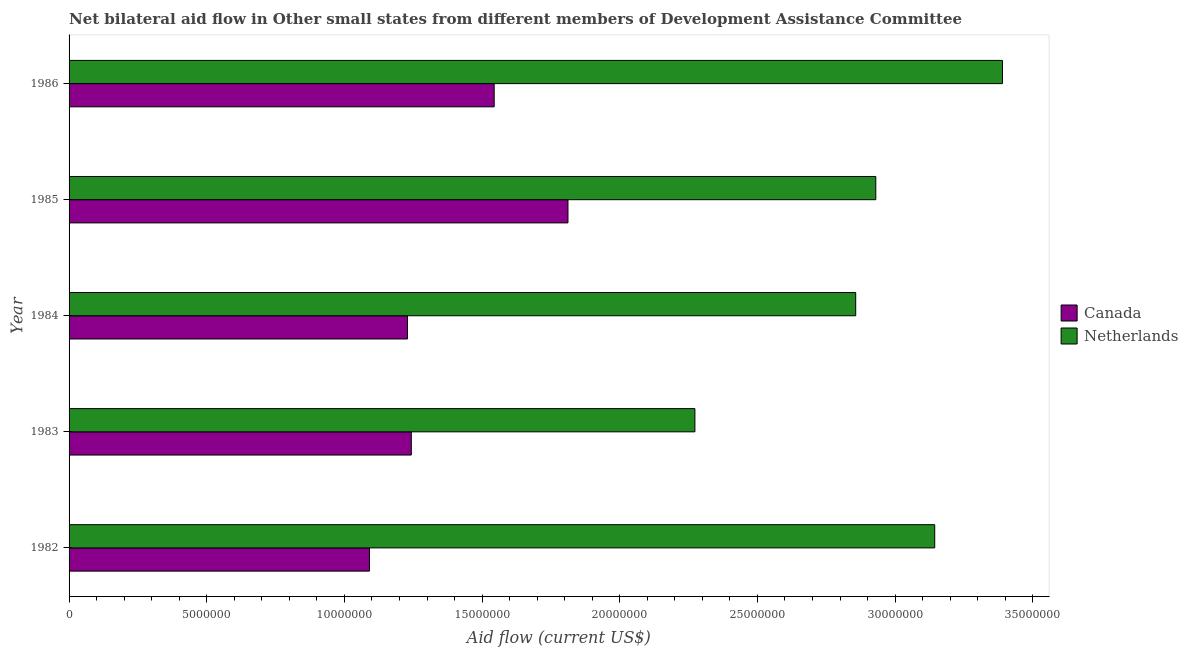How many groups of bars are there?
Your answer should be compact. 5. Are the number of bars per tick equal to the number of legend labels?
Offer a terse response. Yes. Are the number of bars on each tick of the Y-axis equal?
Your response must be concise. Yes. In how many cases, is the number of bars for a given year not equal to the number of legend labels?
Provide a succinct answer. 0. What is the amount of aid given by netherlands in 1985?
Provide a short and direct response. 2.93e+07. Across all years, what is the maximum amount of aid given by canada?
Offer a terse response. 1.81e+07. Across all years, what is the minimum amount of aid given by canada?
Offer a terse response. 1.09e+07. In which year was the amount of aid given by netherlands maximum?
Keep it short and to the point. 1986. What is the total amount of aid given by netherlands in the graph?
Keep it short and to the point. 1.46e+08. What is the difference between the amount of aid given by canada in 1982 and that in 1984?
Your answer should be very brief. -1.38e+06. What is the difference between the amount of aid given by netherlands in 1982 and the amount of aid given by canada in 1984?
Give a very brief answer. 1.92e+07. What is the average amount of aid given by netherlands per year?
Keep it short and to the point. 2.92e+07. In the year 1982, what is the difference between the amount of aid given by canada and amount of aid given by netherlands?
Provide a succinct answer. -2.05e+07. In how many years, is the amount of aid given by canada greater than 31000000 US$?
Offer a very short reply. 0. What is the ratio of the amount of aid given by netherlands in 1983 to that in 1986?
Ensure brevity in your answer.  0.67. Is the difference between the amount of aid given by netherlands in 1982 and 1983 greater than the difference between the amount of aid given by canada in 1982 and 1983?
Give a very brief answer. Yes. What is the difference between the highest and the second highest amount of aid given by canada?
Keep it short and to the point. 2.68e+06. What is the difference between the highest and the lowest amount of aid given by netherlands?
Ensure brevity in your answer.  1.12e+07. In how many years, is the amount of aid given by netherlands greater than the average amount of aid given by netherlands taken over all years?
Your answer should be very brief. 3. Is the sum of the amount of aid given by canada in 1985 and 1986 greater than the maximum amount of aid given by netherlands across all years?
Your answer should be compact. No. What does the 1st bar from the top in 1986 represents?
Offer a terse response. Netherlands. What does the 1st bar from the bottom in 1986 represents?
Make the answer very short. Canada. Are all the bars in the graph horizontal?
Keep it short and to the point. Yes. Does the graph contain grids?
Ensure brevity in your answer.  No. Where does the legend appear in the graph?
Provide a succinct answer. Center right. What is the title of the graph?
Ensure brevity in your answer.  Net bilateral aid flow in Other small states from different members of Development Assistance Committee. Does "External balance on goods" appear as one of the legend labels in the graph?
Your answer should be very brief. No. What is the Aid flow (current US$) of Canada in 1982?
Offer a terse response. 1.09e+07. What is the Aid flow (current US$) of Netherlands in 1982?
Offer a very short reply. 3.14e+07. What is the Aid flow (current US$) in Canada in 1983?
Make the answer very short. 1.24e+07. What is the Aid flow (current US$) of Netherlands in 1983?
Your answer should be compact. 2.27e+07. What is the Aid flow (current US$) in Canada in 1984?
Keep it short and to the point. 1.23e+07. What is the Aid flow (current US$) in Netherlands in 1984?
Your answer should be compact. 2.86e+07. What is the Aid flow (current US$) of Canada in 1985?
Provide a short and direct response. 1.81e+07. What is the Aid flow (current US$) of Netherlands in 1985?
Your response must be concise. 2.93e+07. What is the Aid flow (current US$) of Canada in 1986?
Offer a very short reply. 1.54e+07. What is the Aid flow (current US$) of Netherlands in 1986?
Your answer should be very brief. 3.39e+07. Across all years, what is the maximum Aid flow (current US$) in Canada?
Your answer should be very brief. 1.81e+07. Across all years, what is the maximum Aid flow (current US$) of Netherlands?
Offer a very short reply. 3.39e+07. Across all years, what is the minimum Aid flow (current US$) of Canada?
Keep it short and to the point. 1.09e+07. Across all years, what is the minimum Aid flow (current US$) in Netherlands?
Keep it short and to the point. 2.27e+07. What is the total Aid flow (current US$) in Canada in the graph?
Offer a terse response. 6.92e+07. What is the total Aid flow (current US$) in Netherlands in the graph?
Make the answer very short. 1.46e+08. What is the difference between the Aid flow (current US$) in Canada in 1982 and that in 1983?
Your response must be concise. -1.52e+06. What is the difference between the Aid flow (current US$) in Netherlands in 1982 and that in 1983?
Ensure brevity in your answer.  8.71e+06. What is the difference between the Aid flow (current US$) in Canada in 1982 and that in 1984?
Provide a short and direct response. -1.38e+06. What is the difference between the Aid flow (current US$) of Netherlands in 1982 and that in 1984?
Keep it short and to the point. 2.87e+06. What is the difference between the Aid flow (current US$) of Canada in 1982 and that in 1985?
Your response must be concise. -7.21e+06. What is the difference between the Aid flow (current US$) of Netherlands in 1982 and that in 1985?
Offer a very short reply. 2.14e+06. What is the difference between the Aid flow (current US$) in Canada in 1982 and that in 1986?
Offer a very short reply. -4.53e+06. What is the difference between the Aid flow (current US$) in Netherlands in 1982 and that in 1986?
Your answer should be very brief. -2.46e+06. What is the difference between the Aid flow (current US$) of Netherlands in 1983 and that in 1984?
Your response must be concise. -5.84e+06. What is the difference between the Aid flow (current US$) in Canada in 1983 and that in 1985?
Your response must be concise. -5.69e+06. What is the difference between the Aid flow (current US$) in Netherlands in 1983 and that in 1985?
Keep it short and to the point. -6.57e+06. What is the difference between the Aid flow (current US$) of Canada in 1983 and that in 1986?
Offer a terse response. -3.01e+06. What is the difference between the Aid flow (current US$) in Netherlands in 1983 and that in 1986?
Provide a short and direct response. -1.12e+07. What is the difference between the Aid flow (current US$) in Canada in 1984 and that in 1985?
Make the answer very short. -5.83e+06. What is the difference between the Aid flow (current US$) in Netherlands in 1984 and that in 1985?
Provide a short and direct response. -7.30e+05. What is the difference between the Aid flow (current US$) in Canada in 1984 and that in 1986?
Give a very brief answer. -3.15e+06. What is the difference between the Aid flow (current US$) in Netherlands in 1984 and that in 1986?
Provide a short and direct response. -5.33e+06. What is the difference between the Aid flow (current US$) in Canada in 1985 and that in 1986?
Offer a terse response. 2.68e+06. What is the difference between the Aid flow (current US$) in Netherlands in 1985 and that in 1986?
Provide a succinct answer. -4.60e+06. What is the difference between the Aid flow (current US$) in Canada in 1982 and the Aid flow (current US$) in Netherlands in 1983?
Offer a terse response. -1.18e+07. What is the difference between the Aid flow (current US$) in Canada in 1982 and the Aid flow (current US$) in Netherlands in 1984?
Your answer should be very brief. -1.77e+07. What is the difference between the Aid flow (current US$) of Canada in 1982 and the Aid flow (current US$) of Netherlands in 1985?
Make the answer very short. -1.84e+07. What is the difference between the Aid flow (current US$) in Canada in 1982 and the Aid flow (current US$) in Netherlands in 1986?
Keep it short and to the point. -2.30e+07. What is the difference between the Aid flow (current US$) of Canada in 1983 and the Aid flow (current US$) of Netherlands in 1984?
Offer a very short reply. -1.61e+07. What is the difference between the Aid flow (current US$) of Canada in 1983 and the Aid flow (current US$) of Netherlands in 1985?
Give a very brief answer. -1.69e+07. What is the difference between the Aid flow (current US$) in Canada in 1983 and the Aid flow (current US$) in Netherlands in 1986?
Offer a very short reply. -2.15e+07. What is the difference between the Aid flow (current US$) of Canada in 1984 and the Aid flow (current US$) of Netherlands in 1985?
Your answer should be very brief. -1.70e+07. What is the difference between the Aid flow (current US$) of Canada in 1984 and the Aid flow (current US$) of Netherlands in 1986?
Provide a succinct answer. -2.16e+07. What is the difference between the Aid flow (current US$) in Canada in 1985 and the Aid flow (current US$) in Netherlands in 1986?
Make the answer very short. -1.58e+07. What is the average Aid flow (current US$) in Canada per year?
Offer a terse response. 1.38e+07. What is the average Aid flow (current US$) in Netherlands per year?
Your answer should be compact. 2.92e+07. In the year 1982, what is the difference between the Aid flow (current US$) of Canada and Aid flow (current US$) of Netherlands?
Make the answer very short. -2.05e+07. In the year 1983, what is the difference between the Aid flow (current US$) of Canada and Aid flow (current US$) of Netherlands?
Keep it short and to the point. -1.03e+07. In the year 1984, what is the difference between the Aid flow (current US$) of Canada and Aid flow (current US$) of Netherlands?
Make the answer very short. -1.63e+07. In the year 1985, what is the difference between the Aid flow (current US$) of Canada and Aid flow (current US$) of Netherlands?
Your response must be concise. -1.12e+07. In the year 1986, what is the difference between the Aid flow (current US$) of Canada and Aid flow (current US$) of Netherlands?
Give a very brief answer. -1.85e+07. What is the ratio of the Aid flow (current US$) in Canada in 1982 to that in 1983?
Ensure brevity in your answer.  0.88. What is the ratio of the Aid flow (current US$) of Netherlands in 1982 to that in 1983?
Make the answer very short. 1.38. What is the ratio of the Aid flow (current US$) in Canada in 1982 to that in 1984?
Offer a very short reply. 0.89. What is the ratio of the Aid flow (current US$) in Netherlands in 1982 to that in 1984?
Provide a short and direct response. 1.1. What is the ratio of the Aid flow (current US$) in Canada in 1982 to that in 1985?
Your response must be concise. 0.6. What is the ratio of the Aid flow (current US$) of Netherlands in 1982 to that in 1985?
Ensure brevity in your answer.  1.07. What is the ratio of the Aid flow (current US$) of Canada in 1982 to that in 1986?
Give a very brief answer. 0.71. What is the ratio of the Aid flow (current US$) in Netherlands in 1982 to that in 1986?
Your answer should be very brief. 0.93. What is the ratio of the Aid flow (current US$) in Canada in 1983 to that in 1984?
Offer a very short reply. 1.01. What is the ratio of the Aid flow (current US$) in Netherlands in 1983 to that in 1984?
Ensure brevity in your answer.  0.8. What is the ratio of the Aid flow (current US$) of Canada in 1983 to that in 1985?
Provide a succinct answer. 0.69. What is the ratio of the Aid flow (current US$) of Netherlands in 1983 to that in 1985?
Keep it short and to the point. 0.78. What is the ratio of the Aid flow (current US$) in Canada in 1983 to that in 1986?
Make the answer very short. 0.81. What is the ratio of the Aid flow (current US$) in Netherlands in 1983 to that in 1986?
Your answer should be compact. 0.67. What is the ratio of the Aid flow (current US$) of Canada in 1984 to that in 1985?
Offer a very short reply. 0.68. What is the ratio of the Aid flow (current US$) of Netherlands in 1984 to that in 1985?
Your answer should be very brief. 0.98. What is the ratio of the Aid flow (current US$) in Canada in 1984 to that in 1986?
Your answer should be very brief. 0.8. What is the ratio of the Aid flow (current US$) of Netherlands in 1984 to that in 1986?
Your response must be concise. 0.84. What is the ratio of the Aid flow (current US$) in Canada in 1985 to that in 1986?
Offer a terse response. 1.17. What is the ratio of the Aid flow (current US$) in Netherlands in 1985 to that in 1986?
Provide a succinct answer. 0.86. What is the difference between the highest and the second highest Aid flow (current US$) of Canada?
Ensure brevity in your answer.  2.68e+06. What is the difference between the highest and the second highest Aid flow (current US$) of Netherlands?
Ensure brevity in your answer.  2.46e+06. What is the difference between the highest and the lowest Aid flow (current US$) in Canada?
Your response must be concise. 7.21e+06. What is the difference between the highest and the lowest Aid flow (current US$) of Netherlands?
Give a very brief answer. 1.12e+07. 